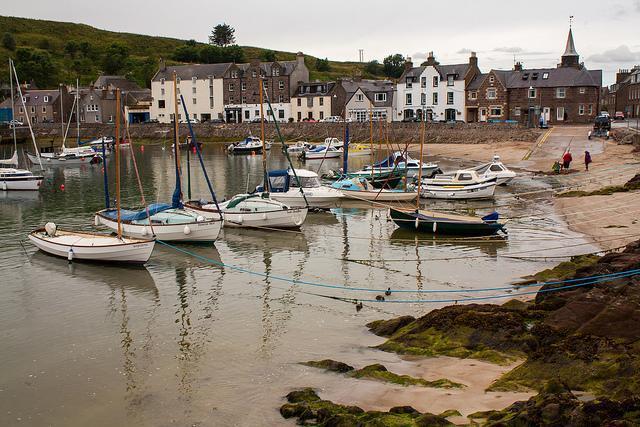How many people are there?
Give a very brief answer. 2. How many boats are visible?
Give a very brief answer. 6. 